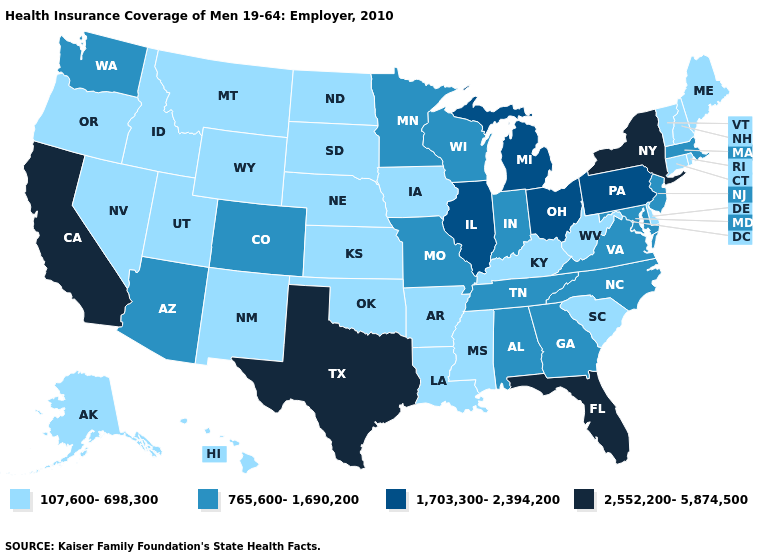Does California have the lowest value in the West?
Concise answer only. No. What is the value of Hawaii?
Short answer required. 107,600-698,300. Name the states that have a value in the range 107,600-698,300?
Quick response, please. Alaska, Arkansas, Connecticut, Delaware, Hawaii, Idaho, Iowa, Kansas, Kentucky, Louisiana, Maine, Mississippi, Montana, Nebraska, Nevada, New Hampshire, New Mexico, North Dakota, Oklahoma, Oregon, Rhode Island, South Carolina, South Dakota, Utah, Vermont, West Virginia, Wyoming. What is the lowest value in states that border Wisconsin?
Give a very brief answer. 107,600-698,300. How many symbols are there in the legend?
Concise answer only. 4. Does California have the highest value in the USA?
Write a very short answer. Yes. Does Alaska have the lowest value in the West?
Be succinct. Yes. What is the highest value in states that border Louisiana?
Concise answer only. 2,552,200-5,874,500. Among the states that border Colorado , does Wyoming have the lowest value?
Quick response, please. Yes. Name the states that have a value in the range 1,703,300-2,394,200?
Be succinct. Illinois, Michigan, Ohio, Pennsylvania. How many symbols are there in the legend?
Short answer required. 4. Does Tennessee have the highest value in the USA?
Concise answer only. No. Does the first symbol in the legend represent the smallest category?
Quick response, please. Yes. Name the states that have a value in the range 2,552,200-5,874,500?
Short answer required. California, Florida, New York, Texas. What is the value of Alabama?
Keep it brief. 765,600-1,690,200. 